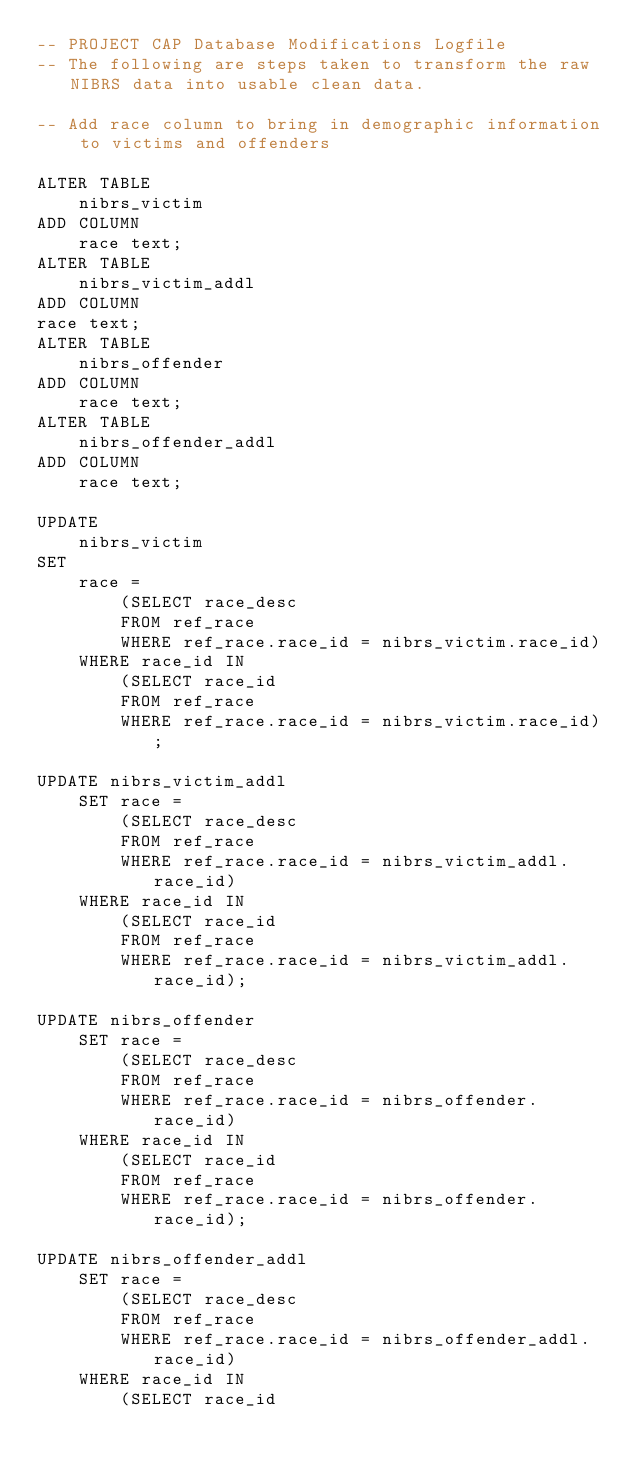Convert code to text. <code><loc_0><loc_0><loc_500><loc_500><_SQL_>-- PROJECT CAP Database Modifications Logfile
-- The following are steps taken to transform the raw NIBRS data into usable clean data.

-- Add race column to bring in demographic information to victims and offenders

ALTER TABLE 
    nibrs_victim 
ADD COLUMN 
    race text;
ALTER TABLE 
    nibrs_victim_addl 
ADD COLUMN 
race text;
ALTER TABLE 
    nibrs_offender 
ADD COLUMN 
    race text;
ALTER TABLE 
    nibrs_offender_addl 
ADD COLUMN 
    race text;

UPDATE 
    nibrs_victim
SET 
    race = 
        (SELECT race_desc 
        FROM ref_race 
        WHERE ref_race.race_id = nibrs_victim.race_id) 
    WHERE race_id IN 
        (SELECT race_id 
        FROM ref_race 
        WHERE ref_race.race_id = nibrs_victim.race_id);

UPDATE nibrs_victim_addl 
    SET race = 
        (SELECT race_desc 
        FROM ref_race 
        WHERE ref_race.race_id = nibrs_victim_addl.race_id) 
    WHERE race_id IN 
        (SELECT race_id 
        FROM ref_race 
        WHERE ref_race.race_id = nibrs_victim_addl.race_id);

UPDATE nibrs_offender
    SET race = 
        (SELECT race_desc 
        FROM ref_race 
        WHERE ref_race.race_id = nibrs_offender.race_id) 
    WHERE race_id IN 
        (SELECT race_id 
        FROM ref_race 
        WHERE ref_race.race_id = nibrs_offender.race_id);

UPDATE nibrs_offender_addl 
    SET race = 
        (SELECT race_desc 
        FROM ref_race 
        WHERE ref_race.race_id = nibrs_offender_addl.race_id) 
    WHERE race_id IN 
        (SELECT race_id </code> 